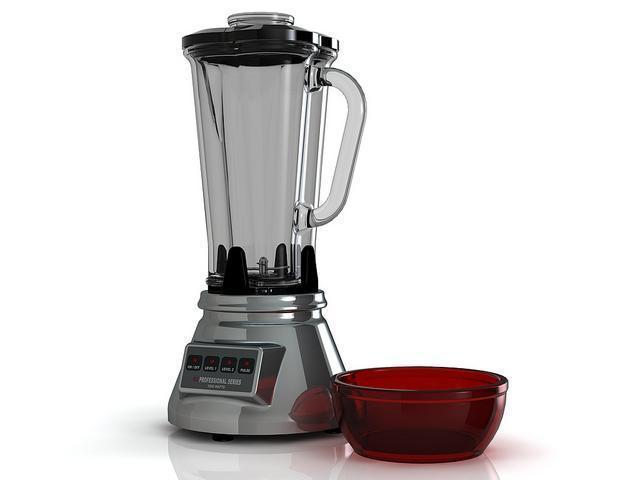How many options does the blender have?
Give a very brief answer. 4. 